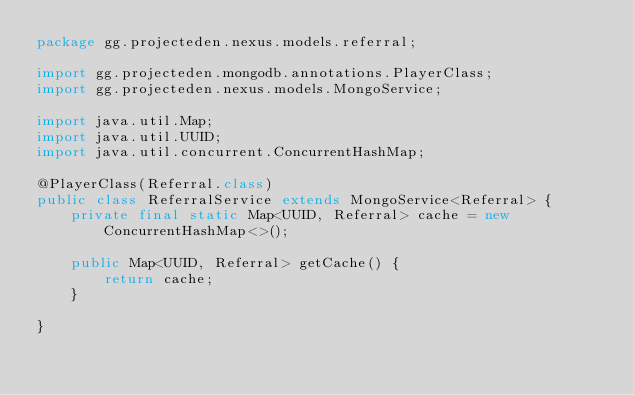Convert code to text. <code><loc_0><loc_0><loc_500><loc_500><_Java_>package gg.projecteden.nexus.models.referral;

import gg.projecteden.mongodb.annotations.PlayerClass;
import gg.projecteden.nexus.models.MongoService;

import java.util.Map;
import java.util.UUID;
import java.util.concurrent.ConcurrentHashMap;

@PlayerClass(Referral.class)
public class ReferralService extends MongoService<Referral> {
	private final static Map<UUID, Referral> cache = new ConcurrentHashMap<>();

	public Map<UUID, Referral> getCache() {
		return cache;
	}

}
</code> 